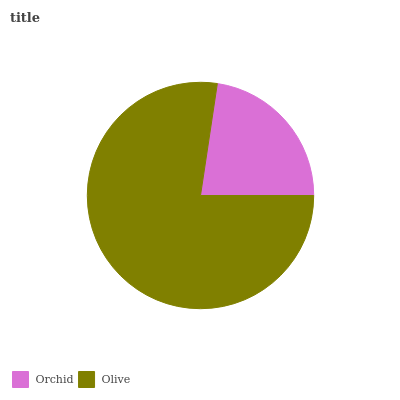Is Orchid the minimum?
Answer yes or no. Yes. Is Olive the maximum?
Answer yes or no. Yes. Is Olive the minimum?
Answer yes or no. No. Is Olive greater than Orchid?
Answer yes or no. Yes. Is Orchid less than Olive?
Answer yes or no. Yes. Is Orchid greater than Olive?
Answer yes or no. No. Is Olive less than Orchid?
Answer yes or no. No. Is Olive the high median?
Answer yes or no. Yes. Is Orchid the low median?
Answer yes or no. Yes. Is Orchid the high median?
Answer yes or no. No. Is Olive the low median?
Answer yes or no. No. 